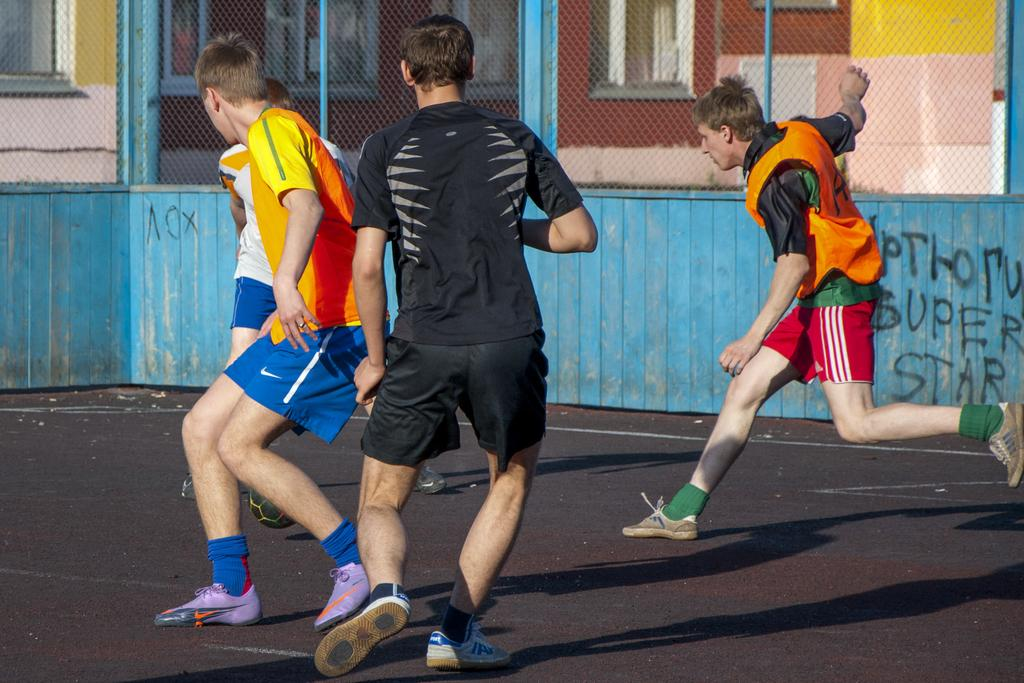<image>
Create a compact narrative representing the image presented. Some boys play soccer in a yard; the words super star are scrawled on a blue  fence alongside. 